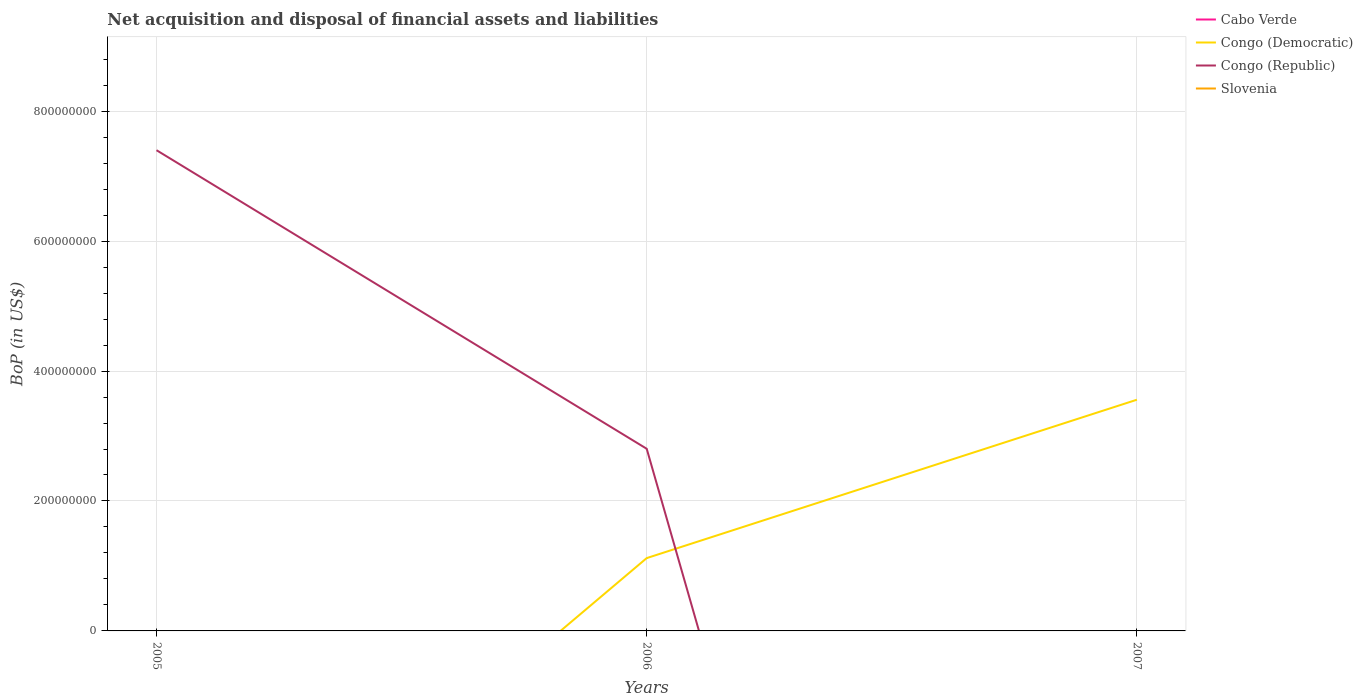How many different coloured lines are there?
Ensure brevity in your answer.  2. Does the line corresponding to Congo (Republic) intersect with the line corresponding to Cabo Verde?
Your response must be concise. Yes. Across all years, what is the maximum Balance of Payments in Congo (Democratic)?
Offer a very short reply. 0. What is the total Balance of Payments in Congo (Democratic) in the graph?
Your answer should be very brief. -2.44e+08. What is the difference between the highest and the second highest Balance of Payments in Congo (Republic)?
Provide a succinct answer. 7.40e+08. Is the Balance of Payments in Slovenia strictly greater than the Balance of Payments in Cabo Verde over the years?
Keep it short and to the point. Yes. How many lines are there?
Keep it short and to the point. 2. What is the difference between two consecutive major ticks on the Y-axis?
Ensure brevity in your answer.  2.00e+08. Does the graph contain any zero values?
Offer a terse response. Yes. Does the graph contain grids?
Offer a very short reply. Yes. Where does the legend appear in the graph?
Provide a short and direct response. Top right. How many legend labels are there?
Ensure brevity in your answer.  4. How are the legend labels stacked?
Make the answer very short. Vertical. What is the title of the graph?
Make the answer very short. Net acquisition and disposal of financial assets and liabilities. What is the label or title of the Y-axis?
Offer a very short reply. BoP (in US$). What is the BoP (in US$) in Congo (Democratic) in 2005?
Offer a very short reply. 0. What is the BoP (in US$) of Congo (Republic) in 2005?
Keep it short and to the point. 7.40e+08. What is the BoP (in US$) in Cabo Verde in 2006?
Ensure brevity in your answer.  0. What is the BoP (in US$) in Congo (Democratic) in 2006?
Provide a short and direct response. 1.12e+08. What is the BoP (in US$) in Congo (Republic) in 2006?
Ensure brevity in your answer.  2.80e+08. What is the BoP (in US$) in Slovenia in 2006?
Your answer should be compact. 0. What is the BoP (in US$) of Congo (Democratic) in 2007?
Ensure brevity in your answer.  3.56e+08. What is the BoP (in US$) in Slovenia in 2007?
Make the answer very short. 0. Across all years, what is the maximum BoP (in US$) in Congo (Democratic)?
Give a very brief answer. 3.56e+08. Across all years, what is the maximum BoP (in US$) of Congo (Republic)?
Give a very brief answer. 7.40e+08. Across all years, what is the minimum BoP (in US$) of Congo (Democratic)?
Give a very brief answer. 0. Across all years, what is the minimum BoP (in US$) of Congo (Republic)?
Provide a succinct answer. 0. What is the total BoP (in US$) of Congo (Democratic) in the graph?
Provide a succinct answer. 4.68e+08. What is the total BoP (in US$) in Congo (Republic) in the graph?
Your response must be concise. 1.02e+09. What is the difference between the BoP (in US$) in Congo (Republic) in 2005 and that in 2006?
Your answer should be very brief. 4.60e+08. What is the difference between the BoP (in US$) of Congo (Democratic) in 2006 and that in 2007?
Your response must be concise. -2.44e+08. What is the average BoP (in US$) of Cabo Verde per year?
Make the answer very short. 0. What is the average BoP (in US$) in Congo (Democratic) per year?
Offer a terse response. 1.56e+08. What is the average BoP (in US$) of Congo (Republic) per year?
Give a very brief answer. 3.40e+08. What is the average BoP (in US$) of Slovenia per year?
Your response must be concise. 0. In the year 2006, what is the difference between the BoP (in US$) of Congo (Democratic) and BoP (in US$) of Congo (Republic)?
Keep it short and to the point. -1.68e+08. What is the ratio of the BoP (in US$) of Congo (Republic) in 2005 to that in 2006?
Your response must be concise. 2.64. What is the ratio of the BoP (in US$) of Congo (Democratic) in 2006 to that in 2007?
Your answer should be compact. 0.32. What is the difference between the highest and the lowest BoP (in US$) of Congo (Democratic)?
Provide a succinct answer. 3.56e+08. What is the difference between the highest and the lowest BoP (in US$) of Congo (Republic)?
Your response must be concise. 7.40e+08. 